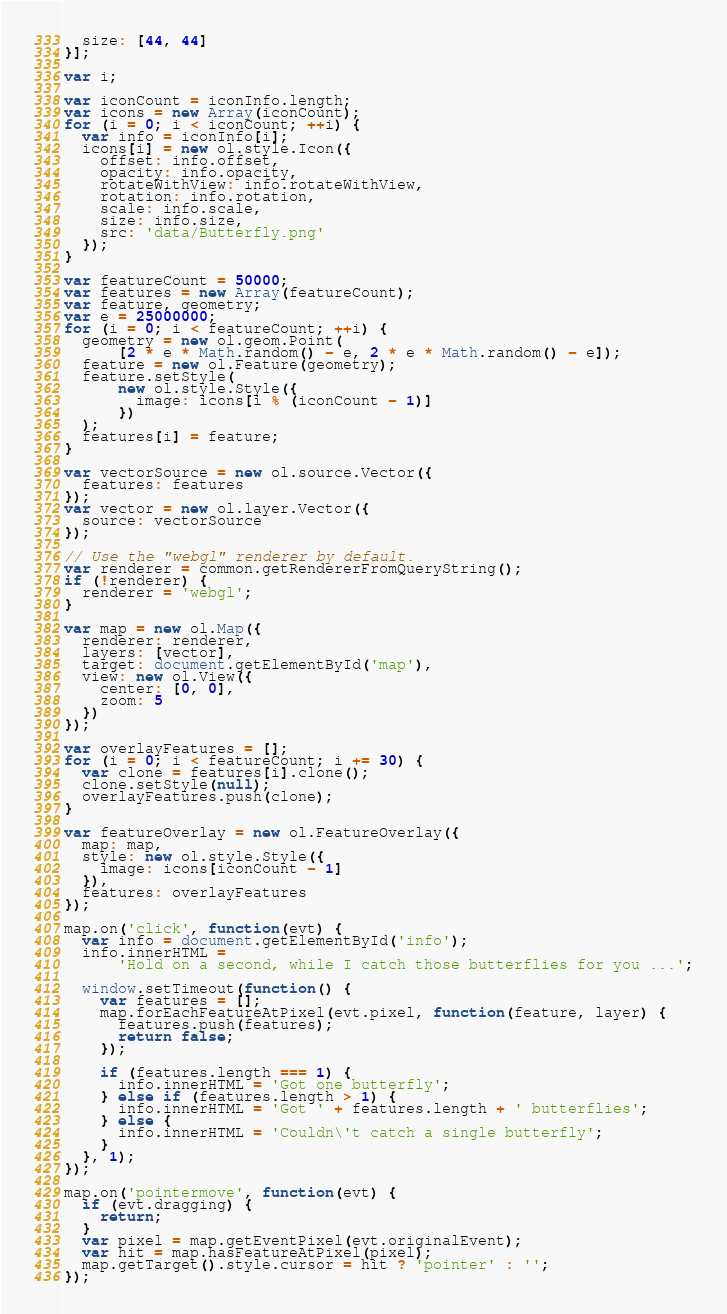Convert code to text. <code><loc_0><loc_0><loc_500><loc_500><_JavaScript_>  size: [44, 44]
}];

var i;

var iconCount = iconInfo.length;
var icons = new Array(iconCount);
for (i = 0; i < iconCount; ++i) {
  var info = iconInfo[i];
  icons[i] = new ol.style.Icon({
    offset: info.offset,
    opacity: info.opacity,
    rotateWithView: info.rotateWithView,
    rotation: info.rotation,
    scale: info.scale,
    size: info.size,
    src: 'data/Butterfly.png'
  });
}

var featureCount = 50000;
var features = new Array(featureCount);
var feature, geometry;
var e = 25000000;
for (i = 0; i < featureCount; ++i) {
  geometry = new ol.geom.Point(
      [2 * e * Math.random() - e, 2 * e * Math.random() - e]);
  feature = new ol.Feature(geometry);
  feature.setStyle(
      new ol.style.Style({
        image: icons[i % (iconCount - 1)]
      })
  );
  features[i] = feature;
}

var vectorSource = new ol.source.Vector({
  features: features
});
var vector = new ol.layer.Vector({
  source: vectorSource
});

// Use the "webgl" renderer by default.
var renderer = common.getRendererFromQueryString();
if (!renderer) {
  renderer = 'webgl';
}

var map = new ol.Map({
  renderer: renderer,
  layers: [vector],
  target: document.getElementById('map'),
  view: new ol.View({
    center: [0, 0],
    zoom: 5
  })
});

var overlayFeatures = [];
for (i = 0; i < featureCount; i += 30) {
  var clone = features[i].clone();
  clone.setStyle(null);
  overlayFeatures.push(clone);
}

var featureOverlay = new ol.FeatureOverlay({
  map: map,
  style: new ol.style.Style({
    image: icons[iconCount - 1]
  }),
  features: overlayFeatures
});

map.on('click', function(evt) {
  var info = document.getElementById('info');
  info.innerHTML =
      'Hold on a second, while I catch those butterflies for you ...';

  window.setTimeout(function() {
    var features = [];
    map.forEachFeatureAtPixel(evt.pixel, function(feature, layer) {
      features.push(features);
      return false;
    });

    if (features.length === 1) {
      info.innerHTML = 'Got one butterfly';
    } else if (features.length > 1) {
      info.innerHTML = 'Got ' + features.length + ' butterflies';
    } else {
      info.innerHTML = 'Couldn\'t catch a single butterfly';
    }
  }, 1);
});

map.on('pointermove', function(evt) {
  if (evt.dragging) {
    return;
  }
  var pixel = map.getEventPixel(evt.originalEvent);
  var hit = map.hasFeatureAtPixel(pixel);
  map.getTarget().style.cursor = hit ? 'pointer' : '';
});
</code> 